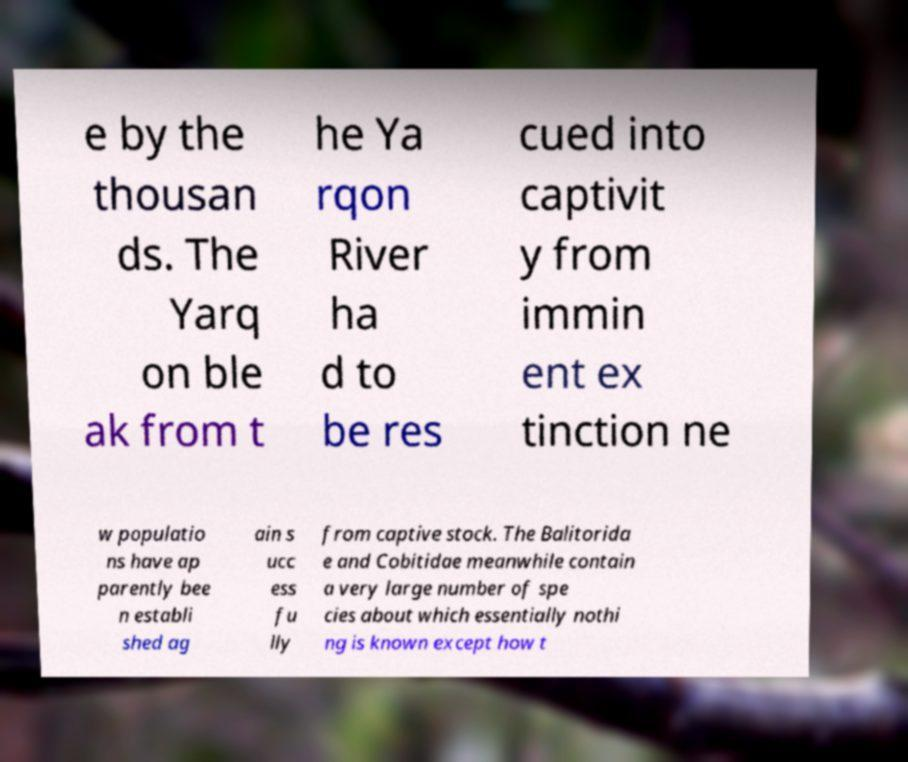Can you accurately transcribe the text from the provided image for me? e by the thousan ds. The Yarq on ble ak from t he Ya rqon River ha d to be res cued into captivit y from immin ent ex tinction ne w populatio ns have ap parently bee n establi shed ag ain s ucc ess fu lly from captive stock. The Balitorida e and Cobitidae meanwhile contain a very large number of spe cies about which essentially nothi ng is known except how t 